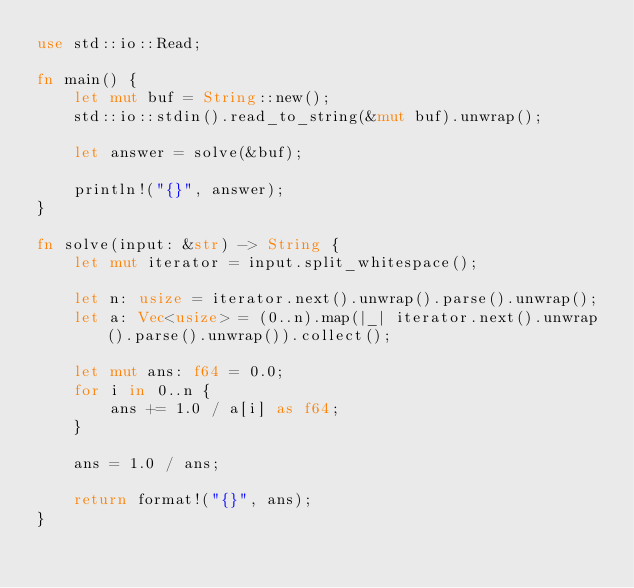Convert code to text. <code><loc_0><loc_0><loc_500><loc_500><_Rust_>use std::io::Read;

fn main() {
    let mut buf = String::new();
    std::io::stdin().read_to_string(&mut buf).unwrap();

    let answer = solve(&buf);

    println!("{}", answer);
}

fn solve(input: &str) -> String {
    let mut iterator = input.split_whitespace();

    let n: usize = iterator.next().unwrap().parse().unwrap();
    let a: Vec<usize> = (0..n).map(|_| iterator.next().unwrap().parse().unwrap()).collect();

    let mut ans: f64 = 0.0;
    for i in 0..n {
        ans += 1.0 / a[i] as f64;
    }

    ans = 1.0 / ans;

    return format!("{}", ans);
}
</code> 